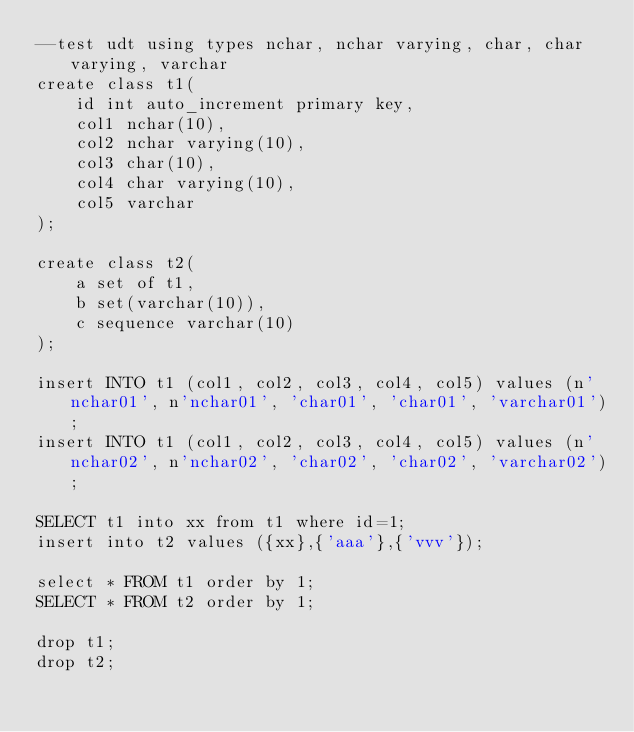Convert code to text. <code><loc_0><loc_0><loc_500><loc_500><_SQL_>--test udt using types nchar, nchar varying, char, char varying, varchar
create class t1(
	id int auto_increment primary key,
	col1 nchar(10),
	col2 nchar varying(10),
	col3 char(10),
	col4 char varying(10),
	col5 varchar
);

create class t2(
	a set of t1,
	b set(varchar(10)),
	c sequence varchar(10)
);

insert INTO t1 (col1, col2, col3, col4, col5) values (n'nchar01', n'nchar01', 'char01', 'char01', 'varchar01');
insert INTO t1 (col1, col2, col3, col4, col5) values (n'nchar02', n'nchar02', 'char02', 'char02', 'varchar02');

SELECT t1 into xx from t1 where id=1;
insert into t2 values ({xx},{'aaa'},{'vvv'});

select * FROM t1 order by 1;
SELECT * FROM t2 order by 1;

drop t1;
drop t2;
</code> 